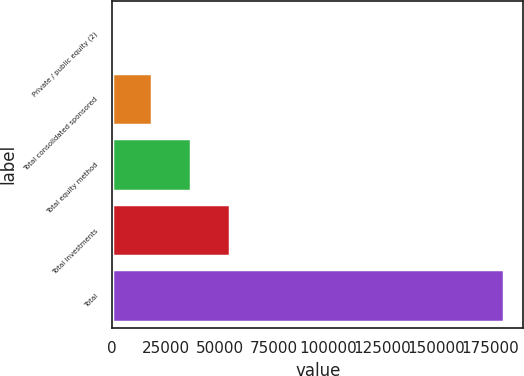Convert chart. <chart><loc_0><loc_0><loc_500><loc_500><bar_chart><fcel>Private / public equity (2)<fcel>Total consolidated sponsored<fcel>Total equity method<fcel>Total investments<fcel>Total<nl><fcel>282<fcel>18395.4<fcel>36508.8<fcel>54622.2<fcel>181416<nl></chart> 